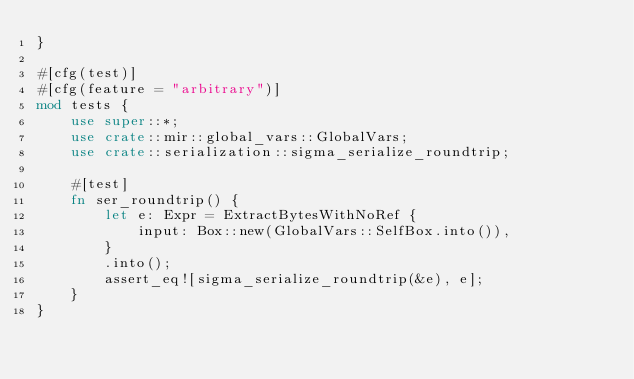Convert code to text. <code><loc_0><loc_0><loc_500><loc_500><_Rust_>}

#[cfg(test)]
#[cfg(feature = "arbitrary")]
mod tests {
    use super::*;
    use crate::mir::global_vars::GlobalVars;
    use crate::serialization::sigma_serialize_roundtrip;

    #[test]
    fn ser_roundtrip() {
        let e: Expr = ExtractBytesWithNoRef {
            input: Box::new(GlobalVars::SelfBox.into()),
        }
        .into();
        assert_eq![sigma_serialize_roundtrip(&e), e];
    }
}
</code> 